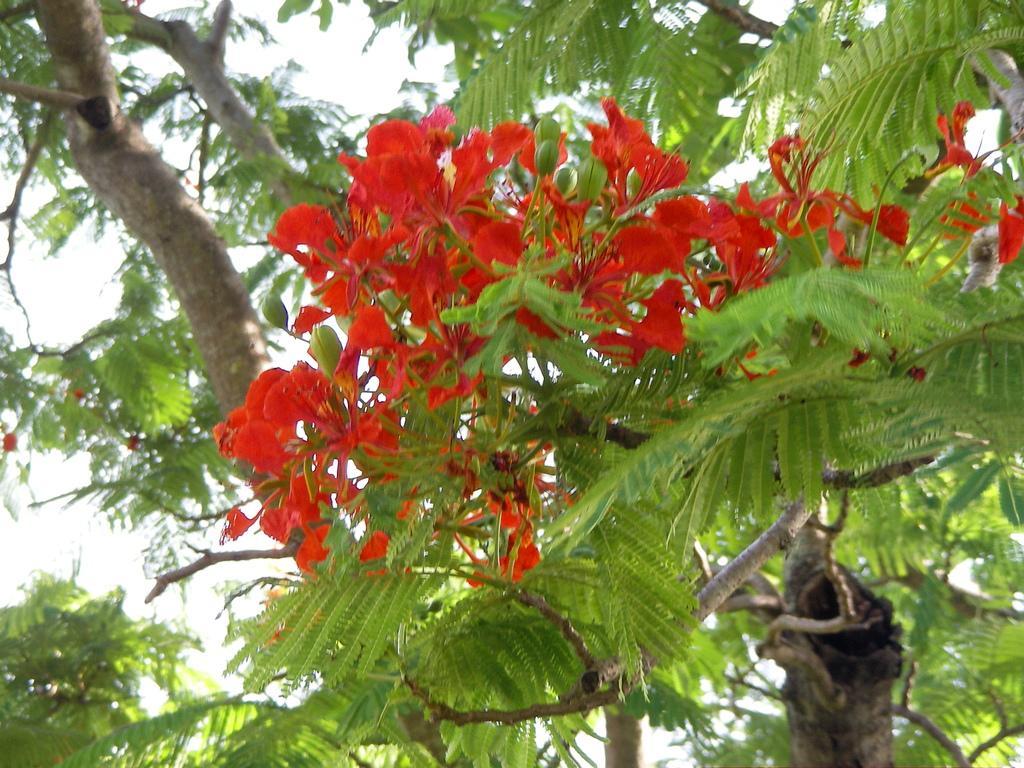Can you describe this image briefly? In this picture we can see flowers, trees and we can see sky in the background. 